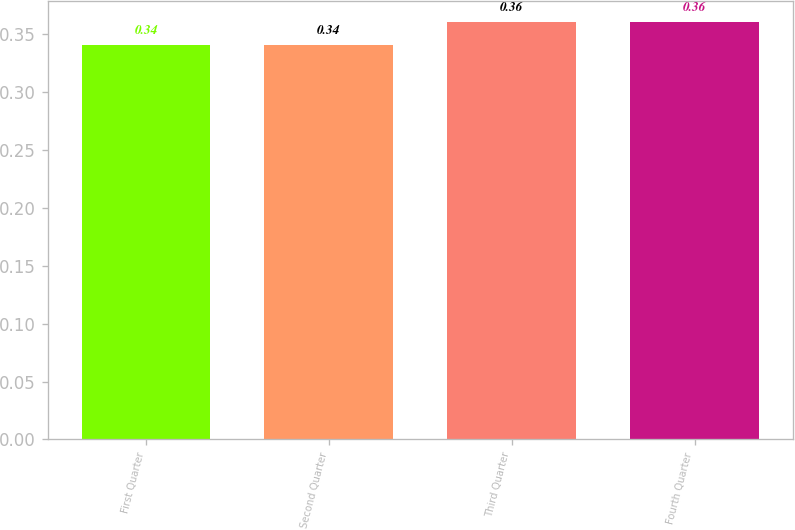Convert chart. <chart><loc_0><loc_0><loc_500><loc_500><bar_chart><fcel>First Quarter<fcel>Second Quarter<fcel>Third Quarter<fcel>Fourth Quarter<nl><fcel>0.34<fcel>0.34<fcel>0.36<fcel>0.36<nl></chart> 